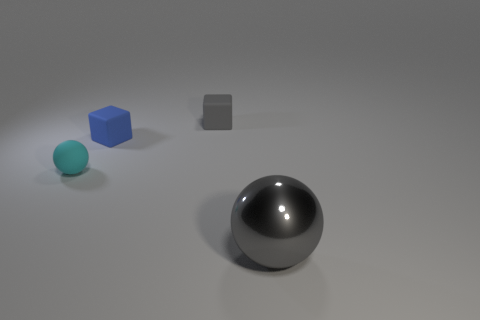Add 2 large cyan matte cubes. How many objects exist? 6 Subtract all gray spheres. How many spheres are left? 1 Subtract 0 yellow cubes. How many objects are left? 4 Subtract all blue matte things. Subtract all big objects. How many objects are left? 2 Add 1 large things. How many large things are left? 2 Add 4 blue rubber blocks. How many blue rubber blocks exist? 5 